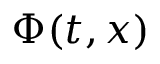Convert formula to latex. <formula><loc_0><loc_0><loc_500><loc_500>\Phi ( t , x )</formula> 